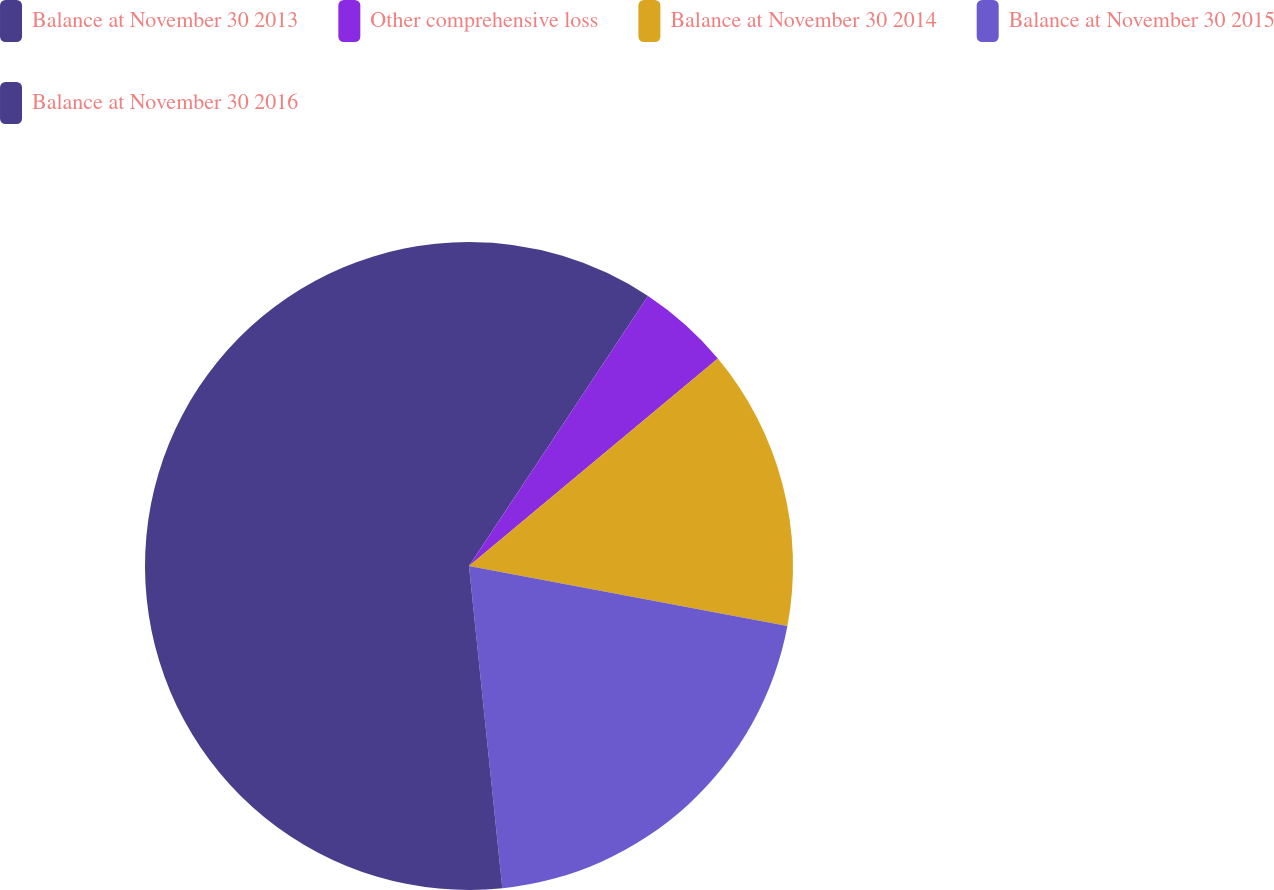<chart> <loc_0><loc_0><loc_500><loc_500><pie_chart><fcel>Balance at November 30 2013<fcel>Other comprehensive loss<fcel>Balance at November 30 2014<fcel>Balance at November 30 2015<fcel>Balance at November 30 2016<nl><fcel>9.32%<fcel>4.62%<fcel>14.02%<fcel>20.4%<fcel>51.64%<nl></chart> 